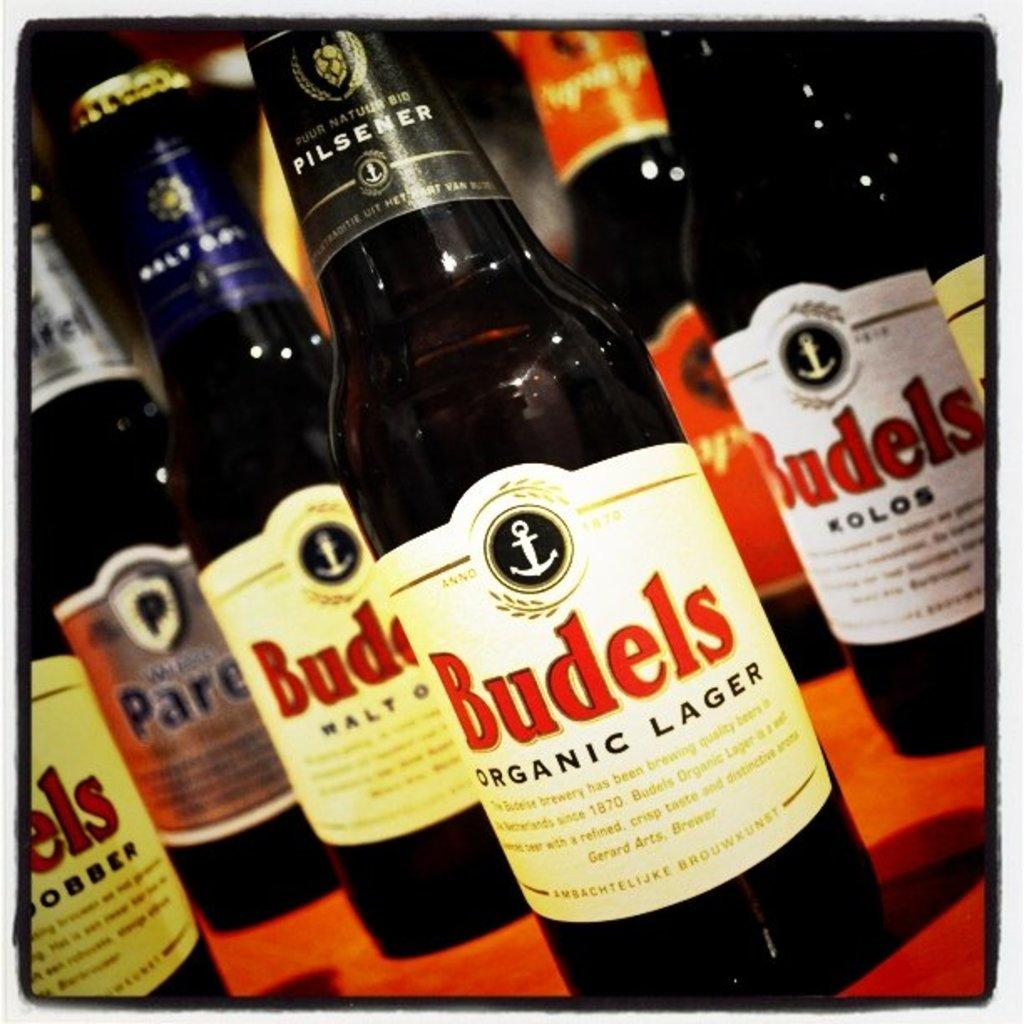<image>
Summarize the visual content of the image. Several bottles of alcohol, most of which have Budels on the label. 